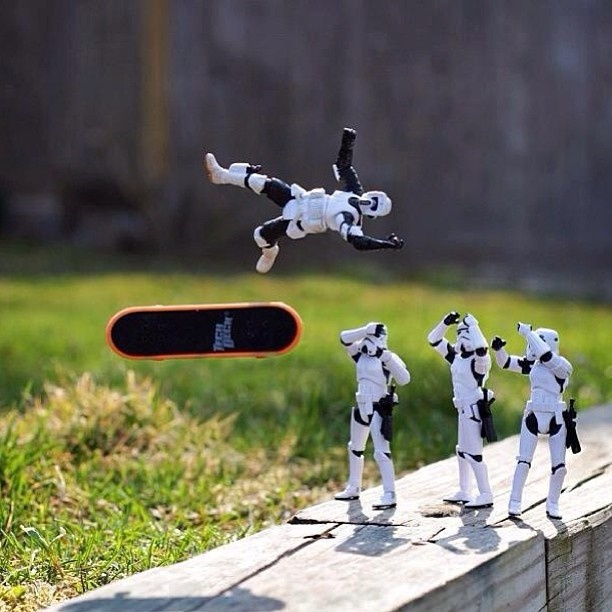Describe the objects in this image and their specific colors. I can see people in black, darkgray, and lavender tones, skateboard in black, maroon, brown, and tan tones, people in black, darkgray, and lightgray tones, people in black, darkgray, and lavender tones, and people in black, lavender, and darkgray tones in this image. 